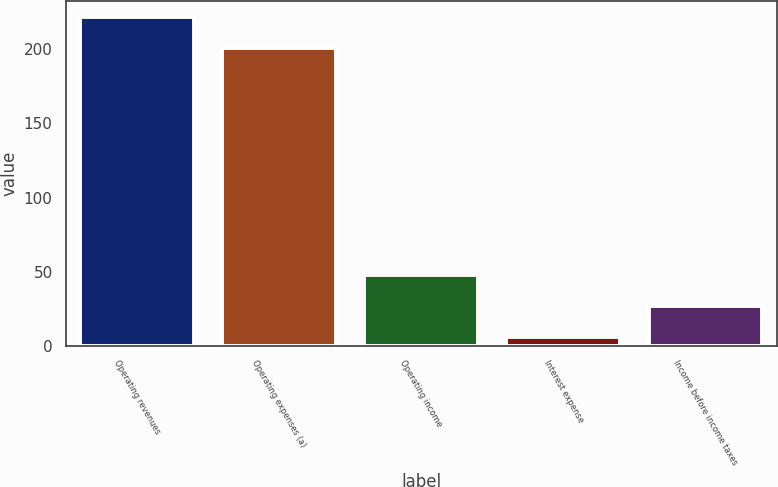Convert chart. <chart><loc_0><loc_0><loc_500><loc_500><bar_chart><fcel>Operating revenues<fcel>Operating expenses (a)<fcel>Operating income<fcel>Interest expense<fcel>Income before income taxes<nl><fcel>221.8<fcel>201<fcel>47.6<fcel>6<fcel>26.8<nl></chart> 